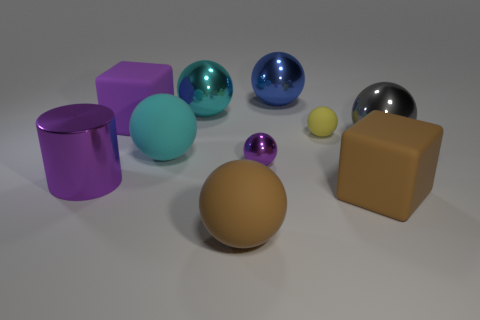Subtract all cyan spheres. How many were subtracted if there are1cyan spheres left? 1 Subtract all yellow balls. How many balls are left? 6 Subtract all cyan blocks. How many cyan spheres are left? 2 Subtract all brown blocks. How many blocks are left? 1 Subtract 3 spheres. How many spheres are left? 4 Subtract all blocks. How many objects are left? 8 Add 4 green matte spheres. How many green matte spheres exist? 4 Subtract 1 purple balls. How many objects are left? 9 Subtract all blue balls. Subtract all blue cubes. How many balls are left? 6 Subtract all big rubber spheres. Subtract all brown matte spheres. How many objects are left? 7 